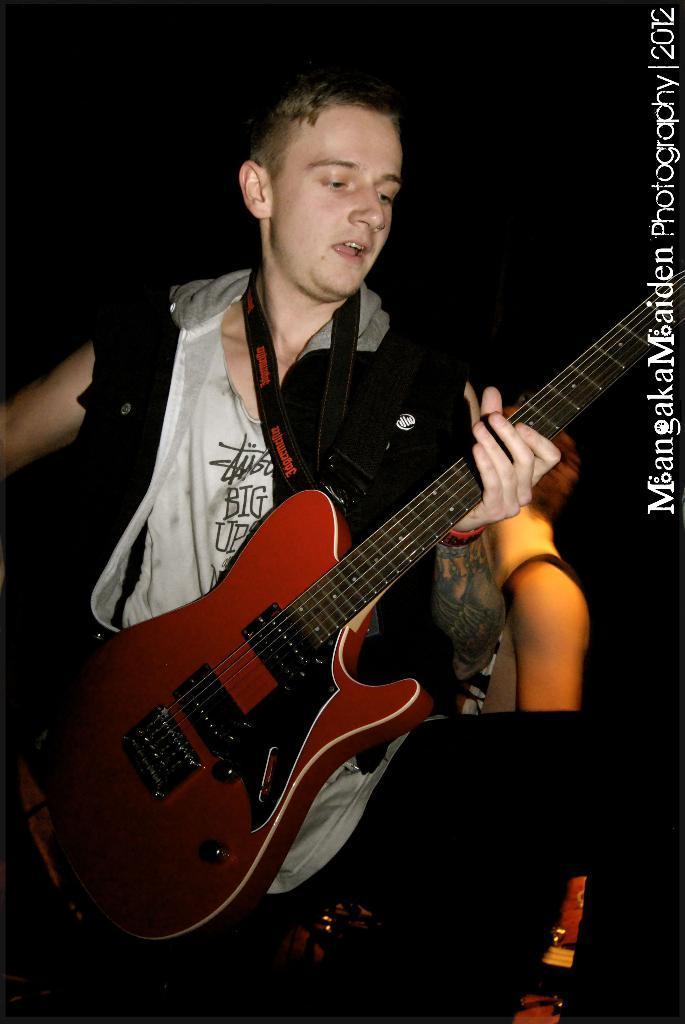Could you give a brief overview of what you see in this image? In this image, There is a boy standing and he is holding a music instrument which is in brown color and he is singing, In the background there are some people standing. 